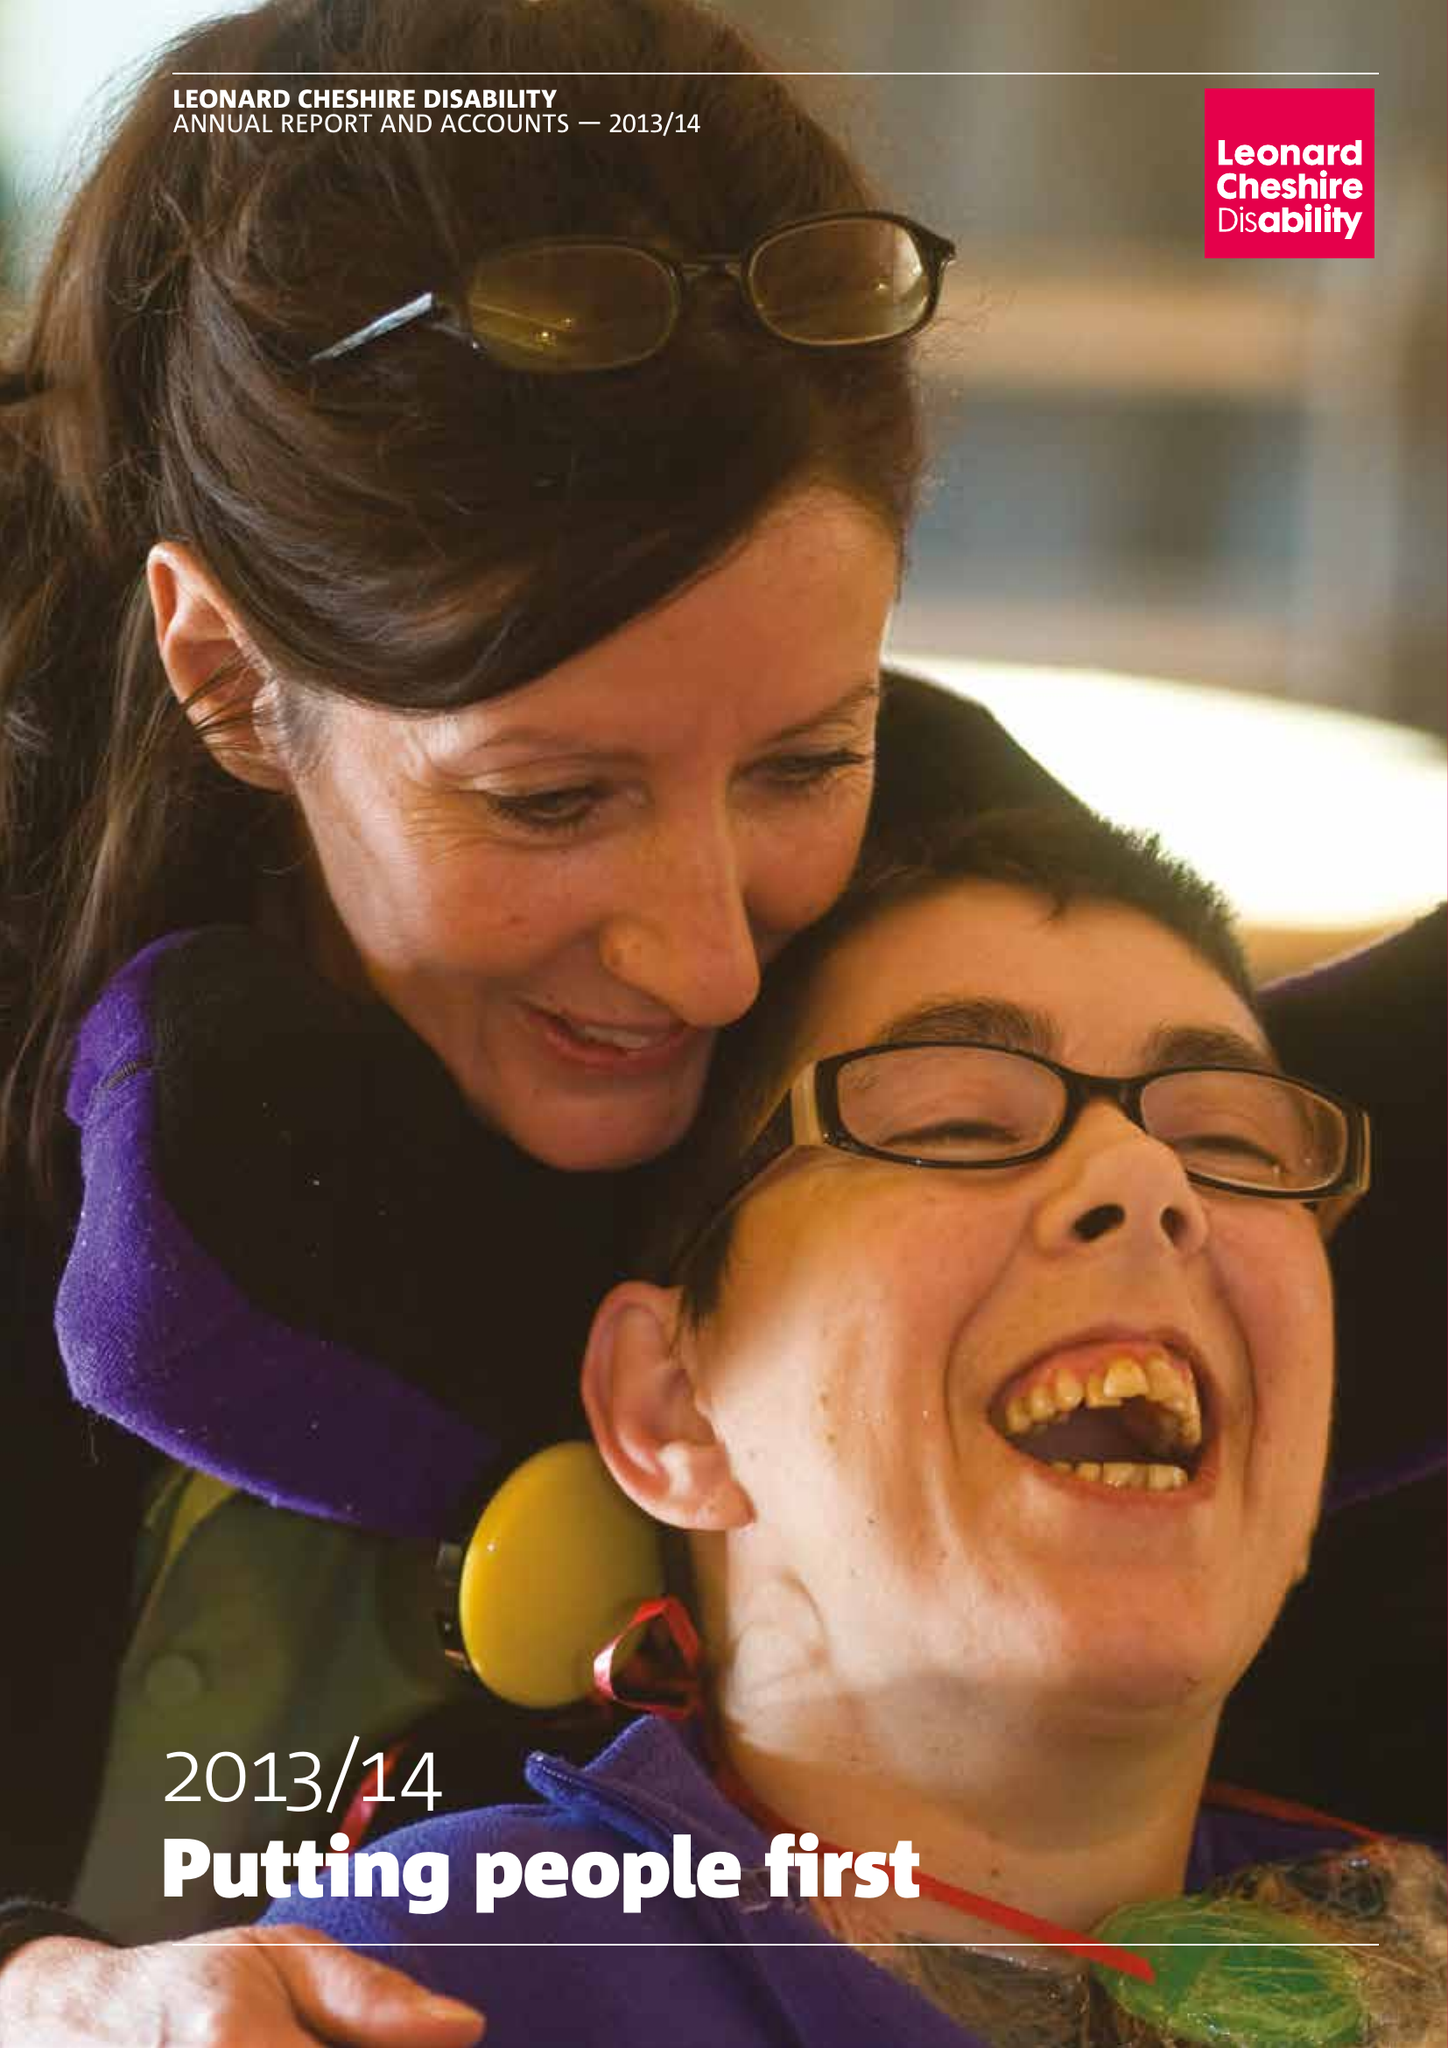What is the value for the address__postcode?
Answer the question using a single word or phrase. SW8 1RL 